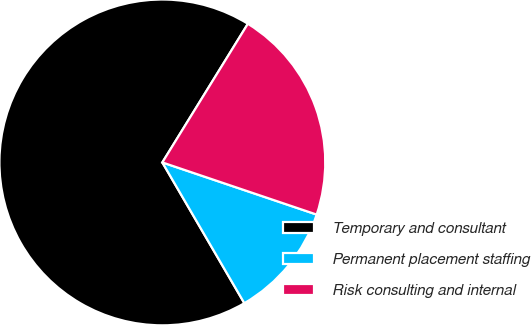Convert chart. <chart><loc_0><loc_0><loc_500><loc_500><pie_chart><fcel>Temporary and consultant<fcel>Permanent placement staffing<fcel>Risk consulting and internal<nl><fcel>67.2%<fcel>11.42%<fcel>21.39%<nl></chart> 